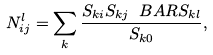<formula> <loc_0><loc_0><loc_500><loc_500>N _ { i j } ^ { l } = \sum _ { k } \frac { S _ { k i } S _ { k j } \ B A R { S _ { k l } } } { S _ { k 0 } } ,</formula> 